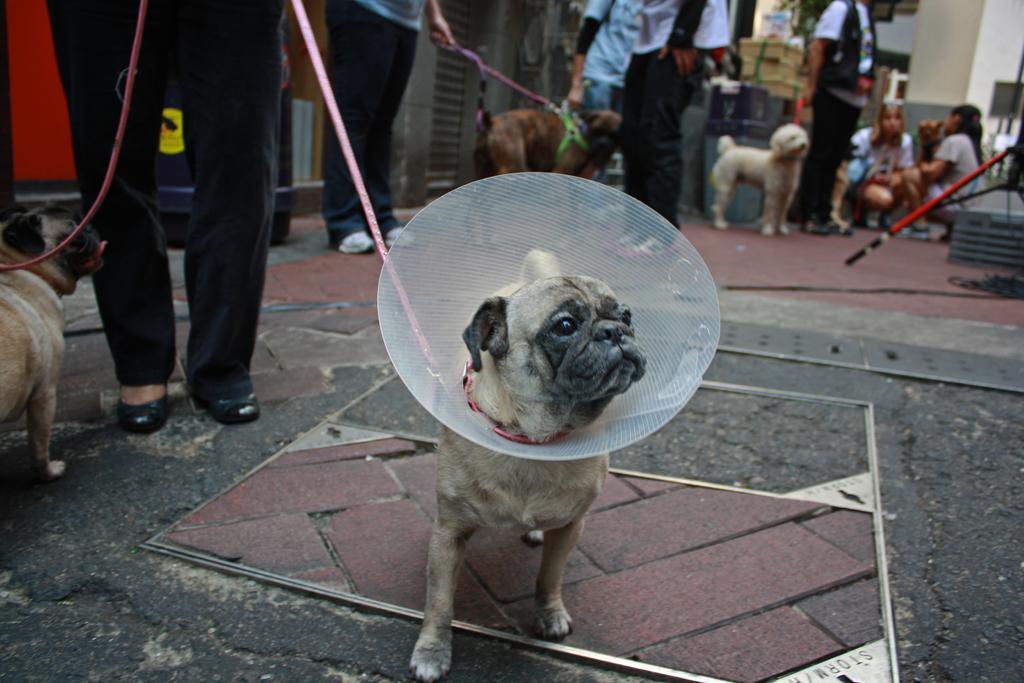How would you summarize this image in a sentence or two? In this picture we can see a dog. There is an object and a leash is visible on this dog. We can see another dog with a leash on the left side. We can see a person holding a dog with a leash at the back. There are a few people visible on the path. We can see an animal on the path. There is a box, pillars and other objects in the background. 